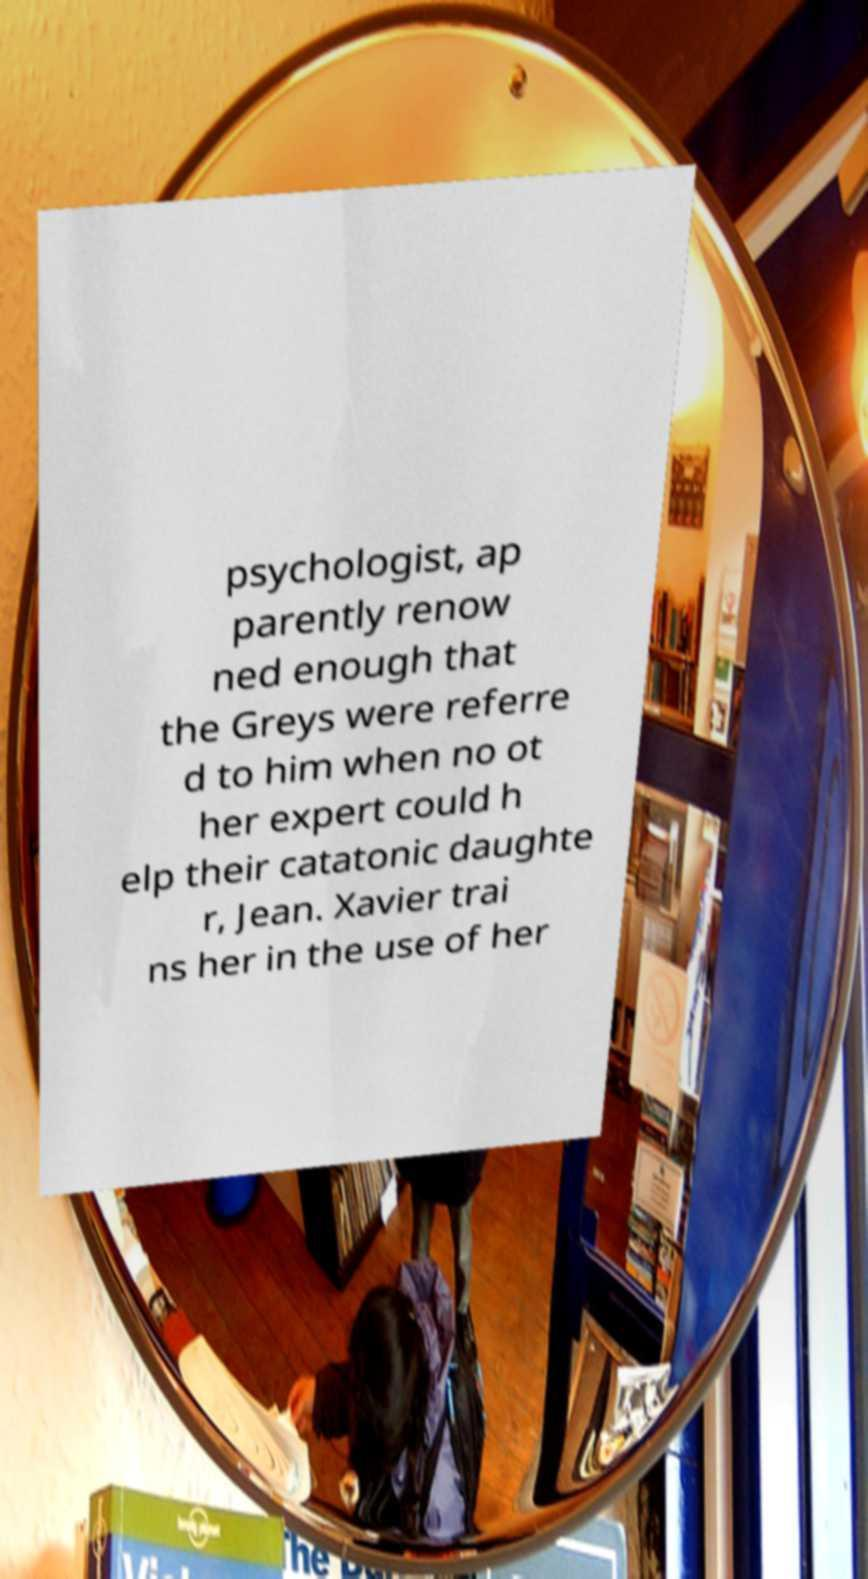For documentation purposes, I need the text within this image transcribed. Could you provide that? psychologist, ap parently renow ned enough that the Greys were referre d to him when no ot her expert could h elp their catatonic daughte r, Jean. Xavier trai ns her in the use of her 